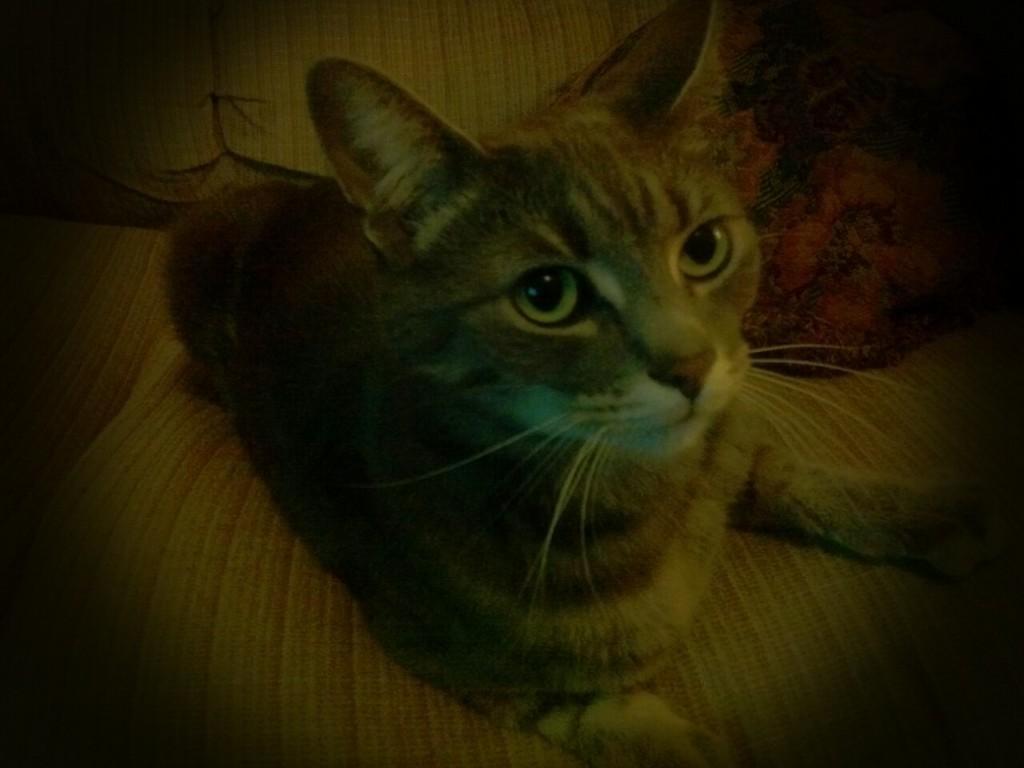Could you give a brief overview of what you see in this image? In this picture there is a cat which is sitting on the couch. Beside the cat I can see the pillows. 